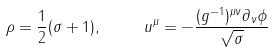<formula> <loc_0><loc_0><loc_500><loc_500>\rho = \frac { 1 } { 2 } ( \sigma + 1 ) , \quad \ u ^ { \mu } = - \frac { ( g ^ { - 1 } ) ^ { \mu \nu } \partial _ { \nu } \phi } { \sqrt { \sigma } }</formula> 